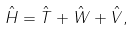Convert formula to latex. <formula><loc_0><loc_0><loc_500><loc_500>\hat { H } = \hat { T } + \hat { W } + \hat { V } ,</formula> 